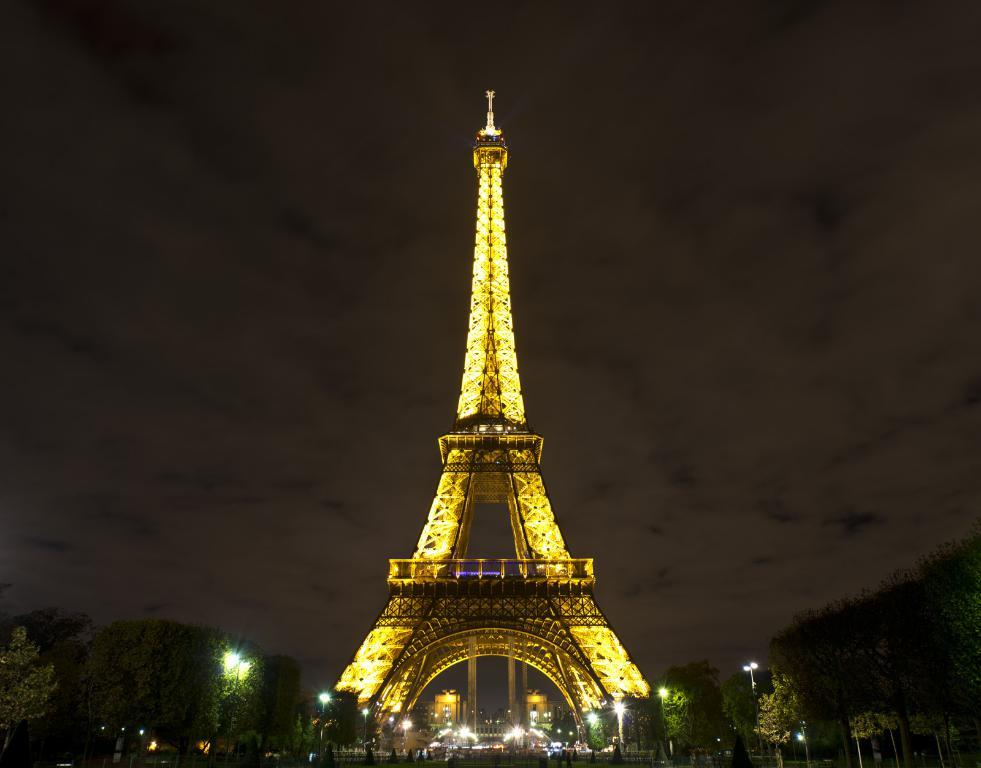What type of vegetation is at the bottom of the image? There are trees at the bottom of the image. What else can be seen at the bottom of the image? There are poles with lights at the bottom of the image. What famous landmark is present in the image? The Eiffel Tower is present in the image. What can be seen in the background of the image? There is a sky visible in the background of the image. What type of skate is being used by the father in the image? There is no father or skate present in the image. How is the chalk being used in the image? There is no chalk present in the image. 